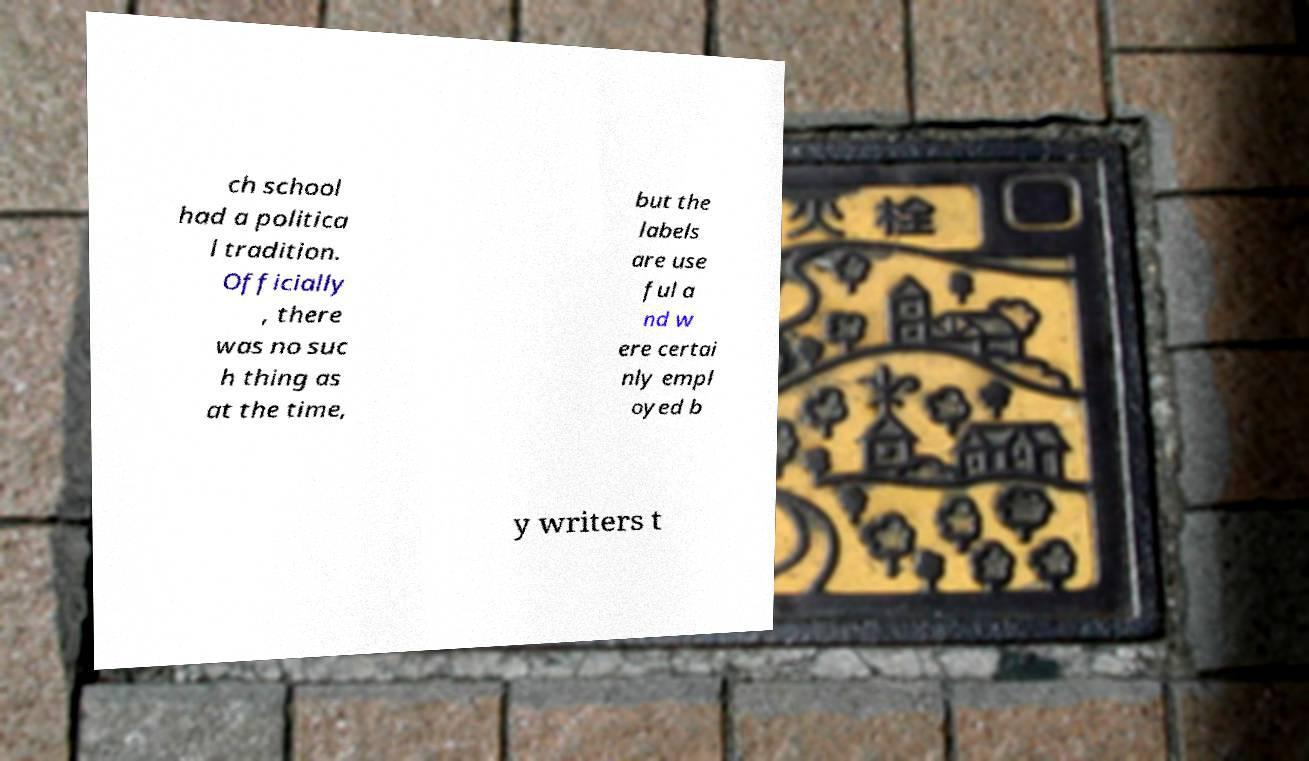Please identify and transcribe the text found in this image. ch school had a politica l tradition. Officially , there was no suc h thing as at the time, but the labels are use ful a nd w ere certai nly empl oyed b y writers t 